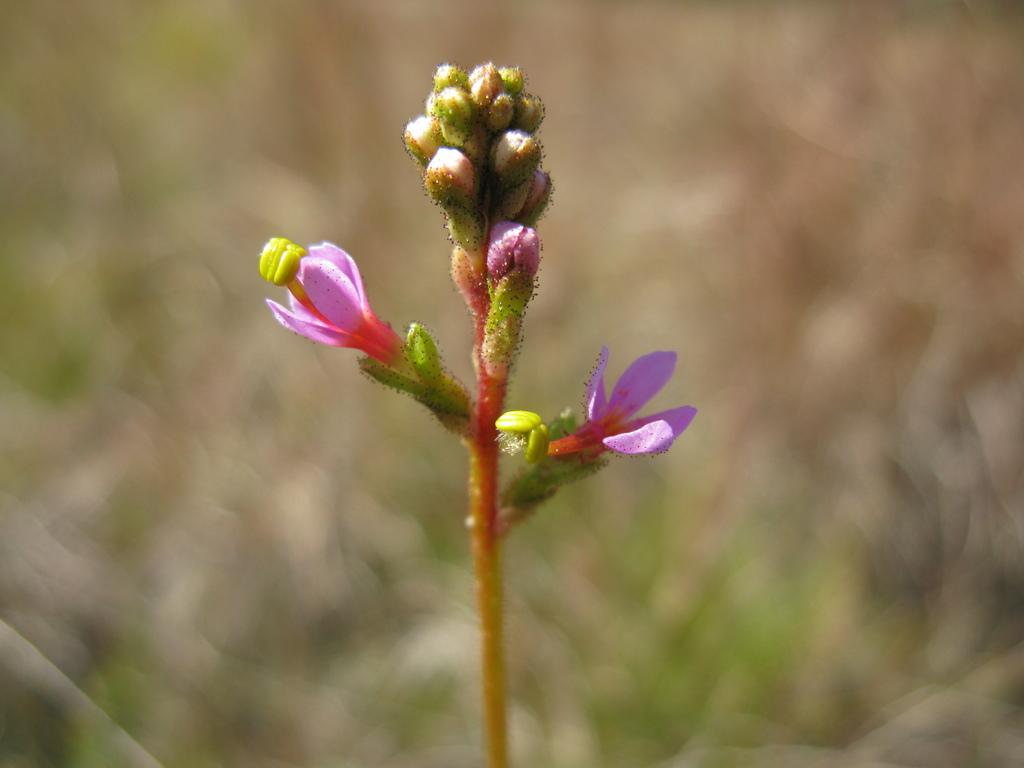What is located in the foreground of the image? There are flowers in the foreground of the image. What can be observed in relation to the flowers in the foreground? There are stems associated with the flowers in the foreground. How would you describe the background of the image? The background of the image is blurred. Can you see any hair on the flowers in the image? There is no hair present on the flowers in the image. 